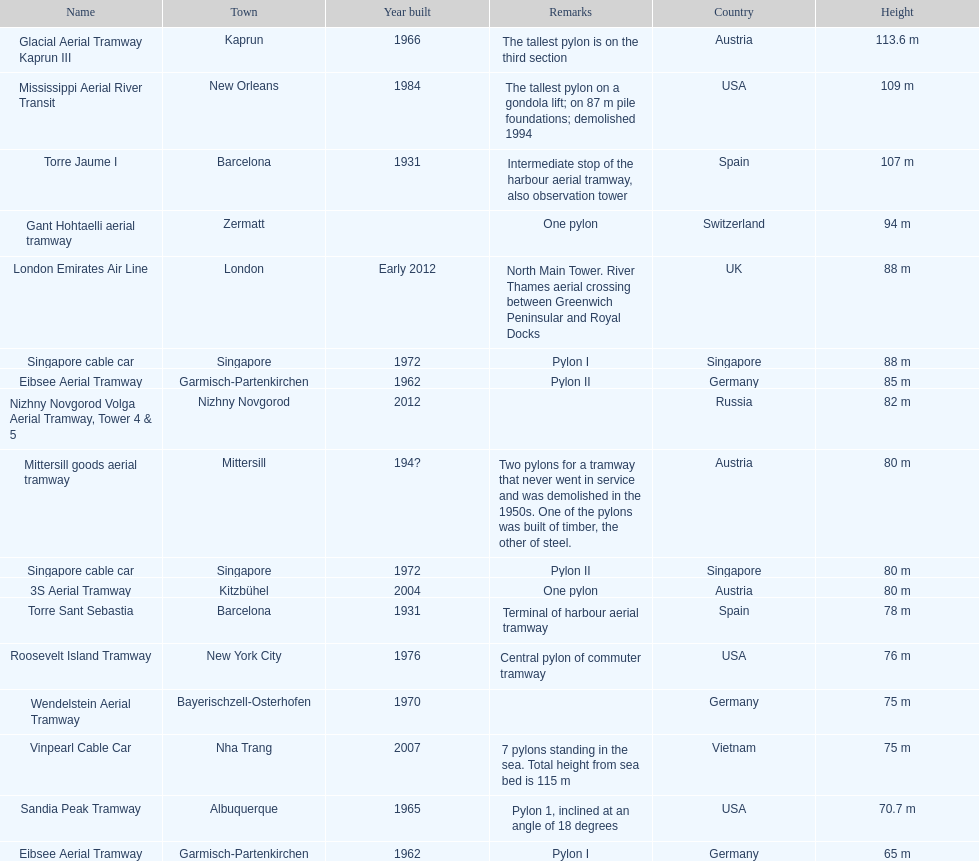What is the pylon with the least height listed here? Eibsee Aerial Tramway. 